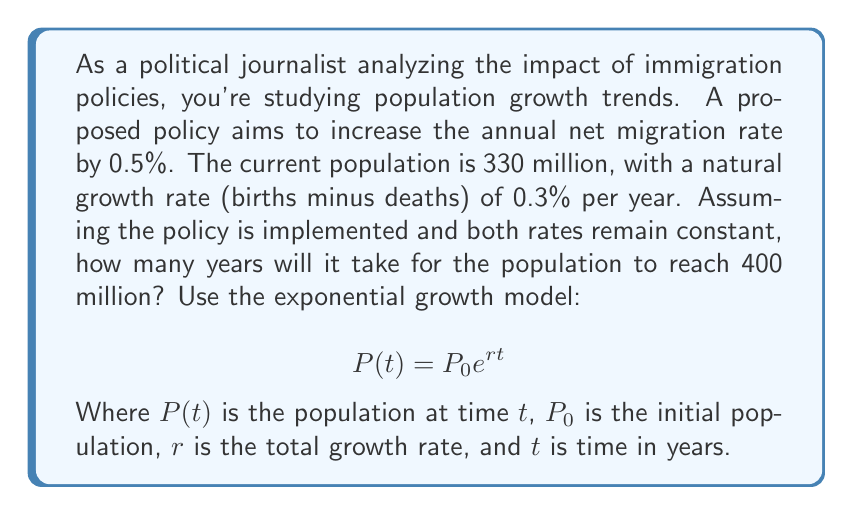Show me your answer to this math problem. To solve this problem, we'll follow these steps:

1. Calculate the total growth rate:
   Natural growth rate = 0.3%
   Increased net migration rate = 0.5%
   Total growth rate (r) = 0.3% + 0.5% = 0.8% = 0.008

2. Set up the exponential growth equation:
   $$400,000,000 = 330,000,000 e^{0.008t}$$

3. Divide both sides by 330,000,000:
   $$\frac{400,000,000}{330,000,000} = e^{0.008t}$$

4. Take the natural log of both sides:
   $$\ln(\frac{400,000,000}{330,000,000}) = 0.008t$$

5. Simplify the left side:
   $$\ln(1.212121) = 0.008t$$

6. Calculate the natural log:
   $$0.192308 = 0.008t$$

7. Solve for t:
   $$t = \frac{0.192308}{0.008} = 24.0385$$

8. Round to the nearest whole year:
   t ≈ 24 years
Answer: It will take approximately 24 years for the population to reach 400 million under the proposed policy. 